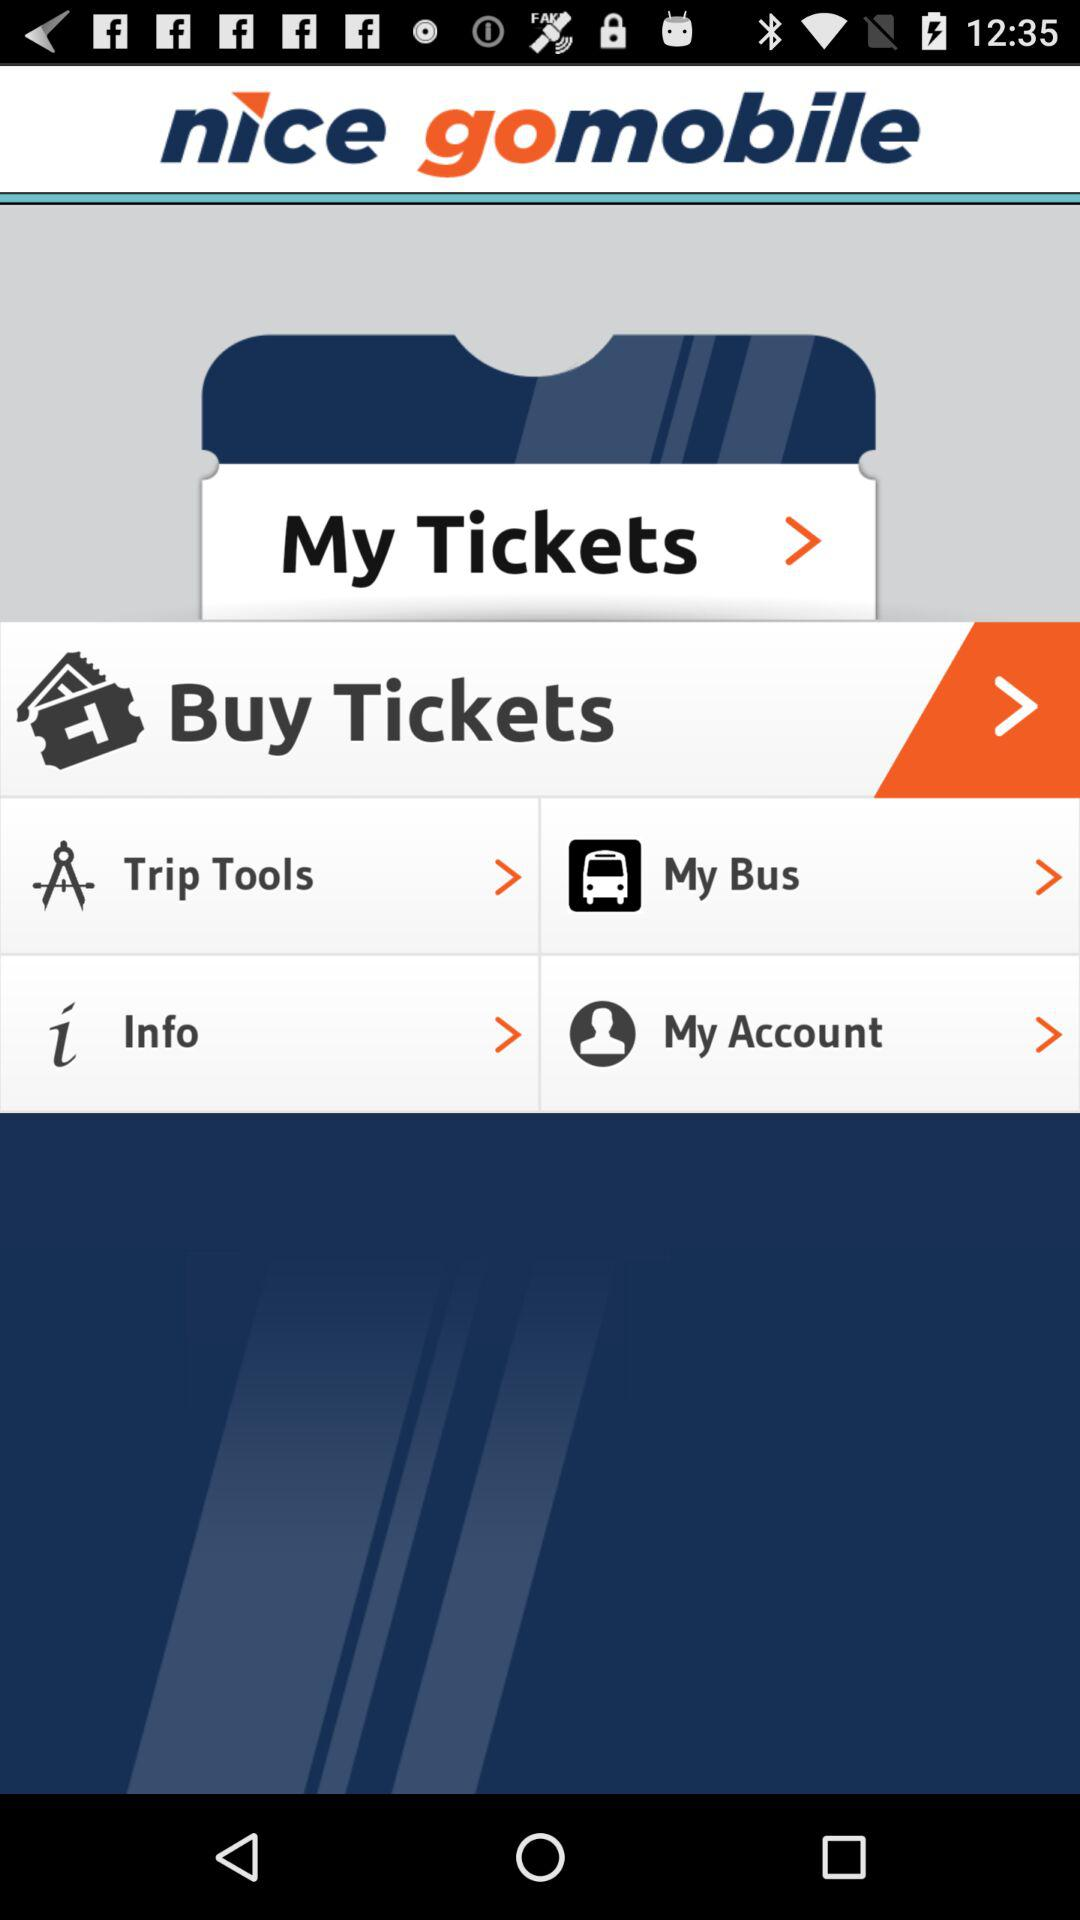What is the application name? The application name is "nice gomobile". 